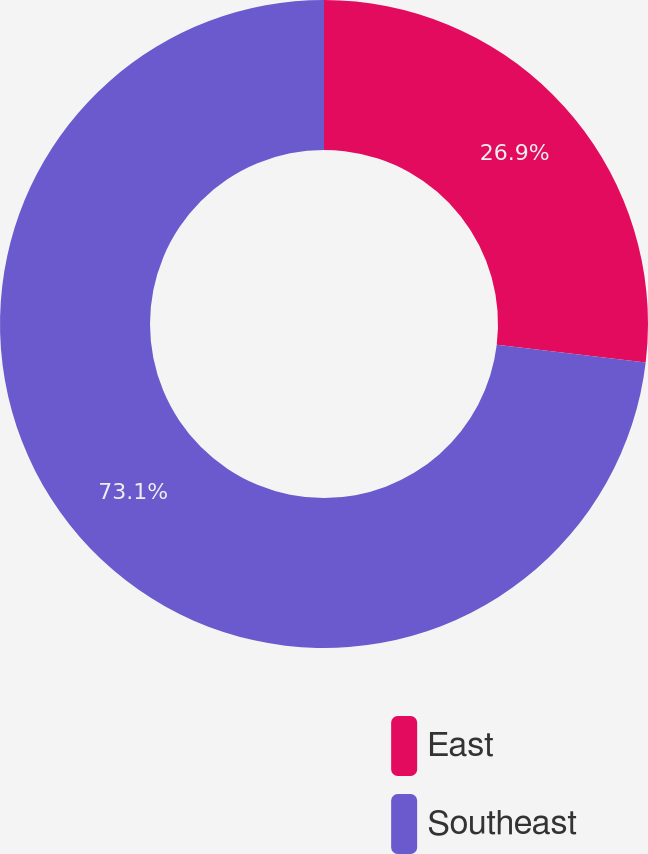Convert chart. <chart><loc_0><loc_0><loc_500><loc_500><pie_chart><fcel>East<fcel>Southeast<nl><fcel>26.9%<fcel>73.1%<nl></chart> 